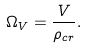<formula> <loc_0><loc_0><loc_500><loc_500>\Omega _ { V } = \frac { V } { \rho _ { c r } } .</formula> 